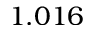<formula> <loc_0><loc_0><loc_500><loc_500>1 . 0 1 6</formula> 